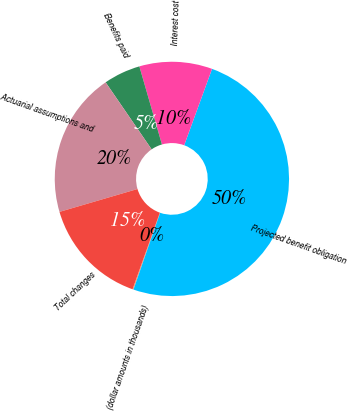Convert chart. <chart><loc_0><loc_0><loc_500><loc_500><pie_chart><fcel>(dollar amounts in thousands)<fcel>Projected benefit obligation<fcel>Interest cost<fcel>Benefits paid<fcel>Actuarial assumptions and<fcel>Total changes<nl><fcel>0.13%<fcel>49.75%<fcel>10.05%<fcel>5.09%<fcel>19.97%<fcel>15.01%<nl></chart> 